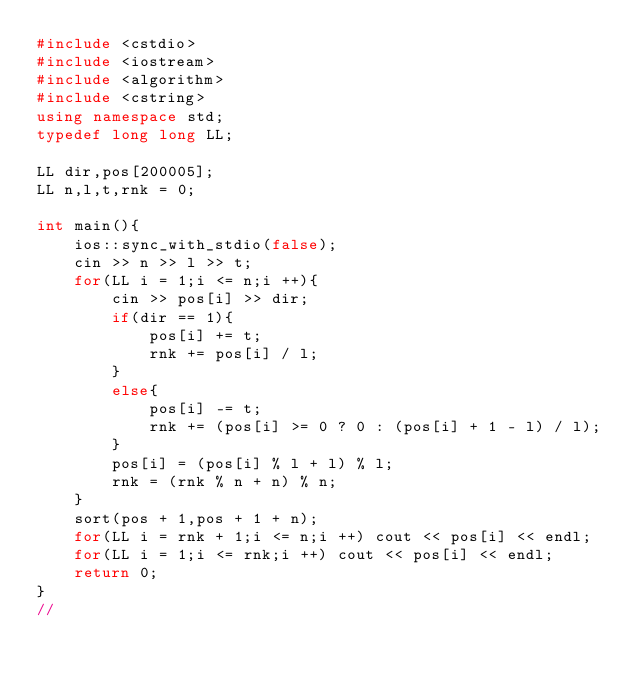Convert code to text. <code><loc_0><loc_0><loc_500><loc_500><_C++_>#include <cstdio>
#include <iostream>
#include <algorithm>
#include <cstring>
using namespace std;
typedef long long LL;

LL dir,pos[200005];
LL n,l,t,rnk = 0;

int main(){
	ios::sync_with_stdio(false);
	cin >> n >> l >> t;
	for(LL i = 1;i <= n;i ++){
		cin >> pos[i] >> dir;
		if(dir == 1){
			pos[i] += t;
			rnk += pos[i] / l;
		}
		else{
			pos[i] -= t;
			rnk += (pos[i] >= 0 ? 0 : (pos[i] + 1 - l) / l);
		}
		pos[i] = (pos[i] % l + l) % l;
		rnk = (rnk % n + n) % n;
	}
	sort(pos + 1,pos + 1 + n);
	for(LL i = rnk + 1;i <= n;i ++) cout << pos[i] << endl;
	for(LL i = 1;i <= rnk;i ++) cout << pos[i] << endl;
    return 0;
}
//</code> 